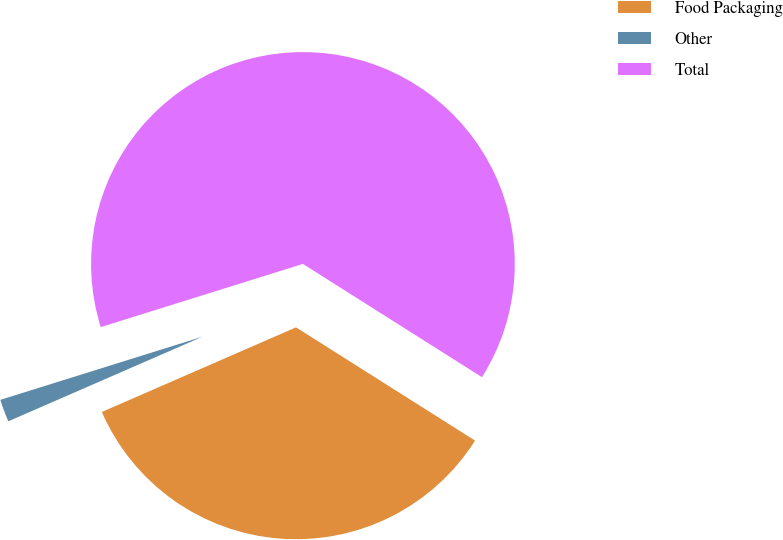Convert chart. <chart><loc_0><loc_0><loc_500><loc_500><pie_chart><fcel>Food Packaging<fcel>Other<fcel>Total<nl><fcel>34.48%<fcel>1.72%<fcel>63.79%<nl></chart> 